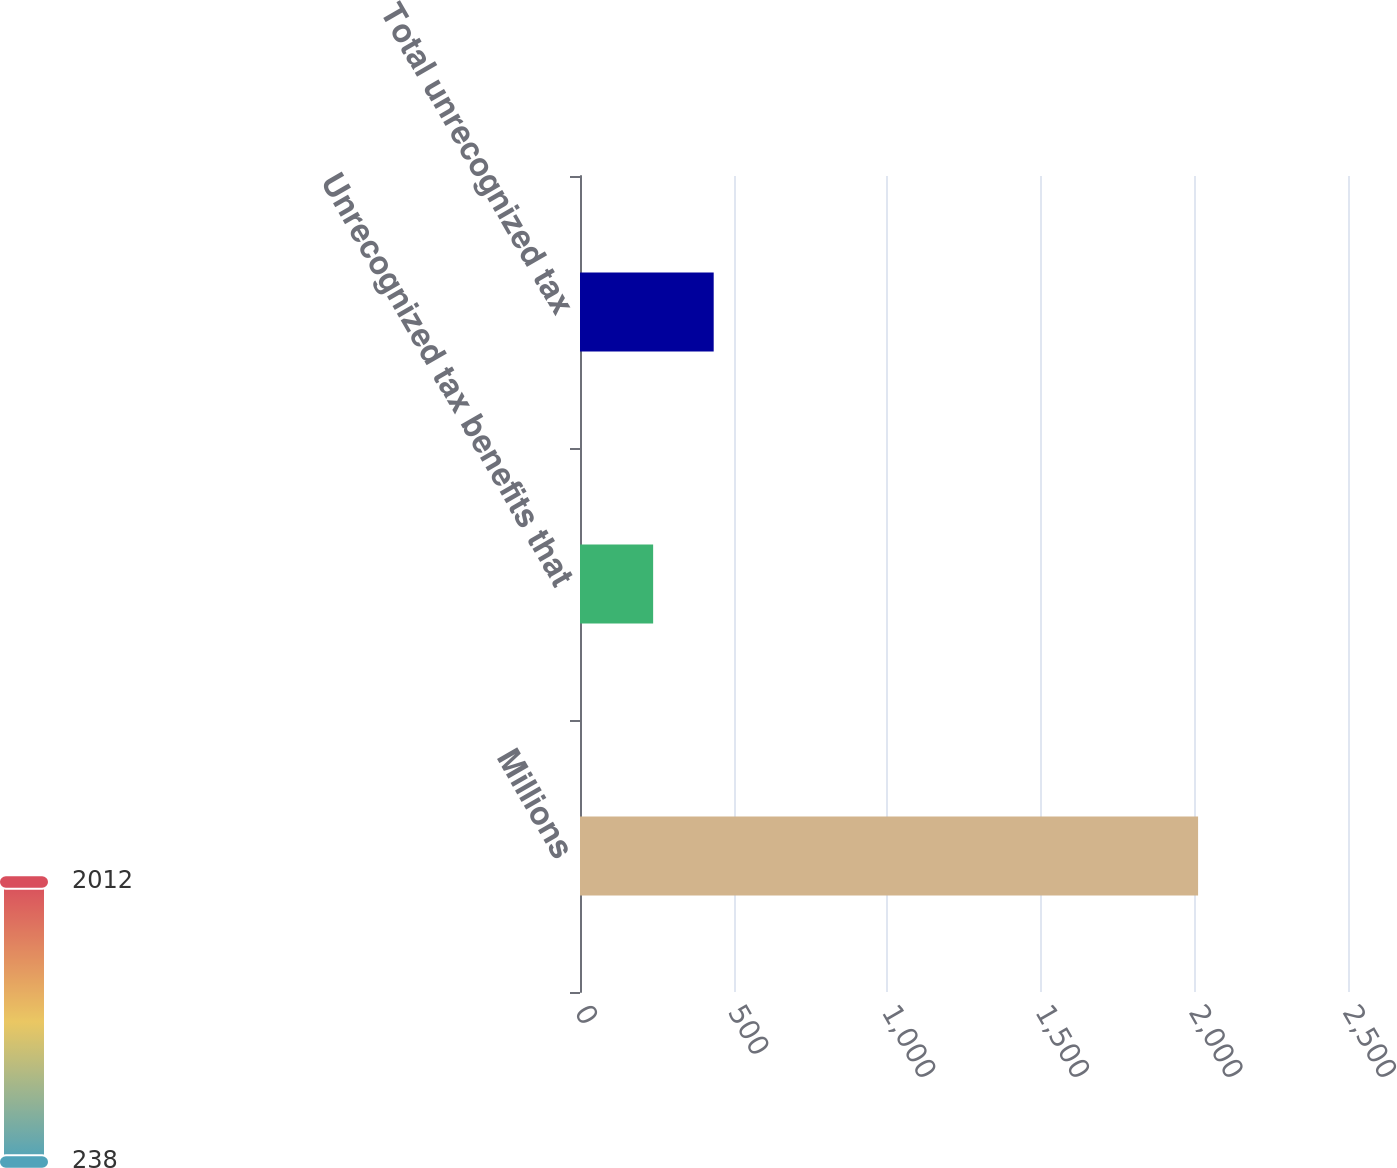<chart> <loc_0><loc_0><loc_500><loc_500><bar_chart><fcel>Millions<fcel>Unrecognized tax benefits that<fcel>Total unrecognized tax<nl><fcel>2012<fcel>238.1<fcel>435.2<nl></chart> 